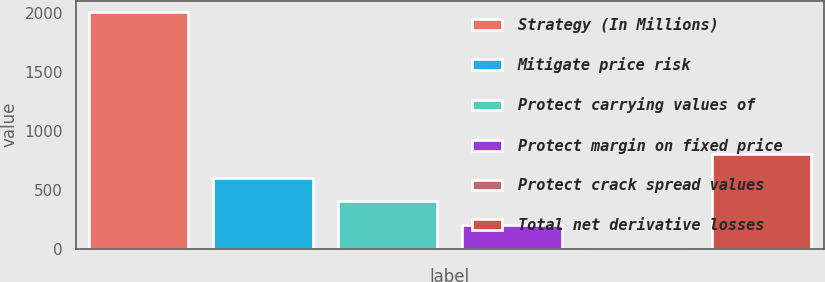Convert chart. <chart><loc_0><loc_0><loc_500><loc_500><bar_chart><fcel>Strategy (In Millions)<fcel>Mitigate price risk<fcel>Protect carrying values of<fcel>Protect margin on fixed price<fcel>Protect crack spread values<fcel>Total net derivative losses<nl><fcel>2002<fcel>601.3<fcel>401.2<fcel>201.1<fcel>1<fcel>801.4<nl></chart> 